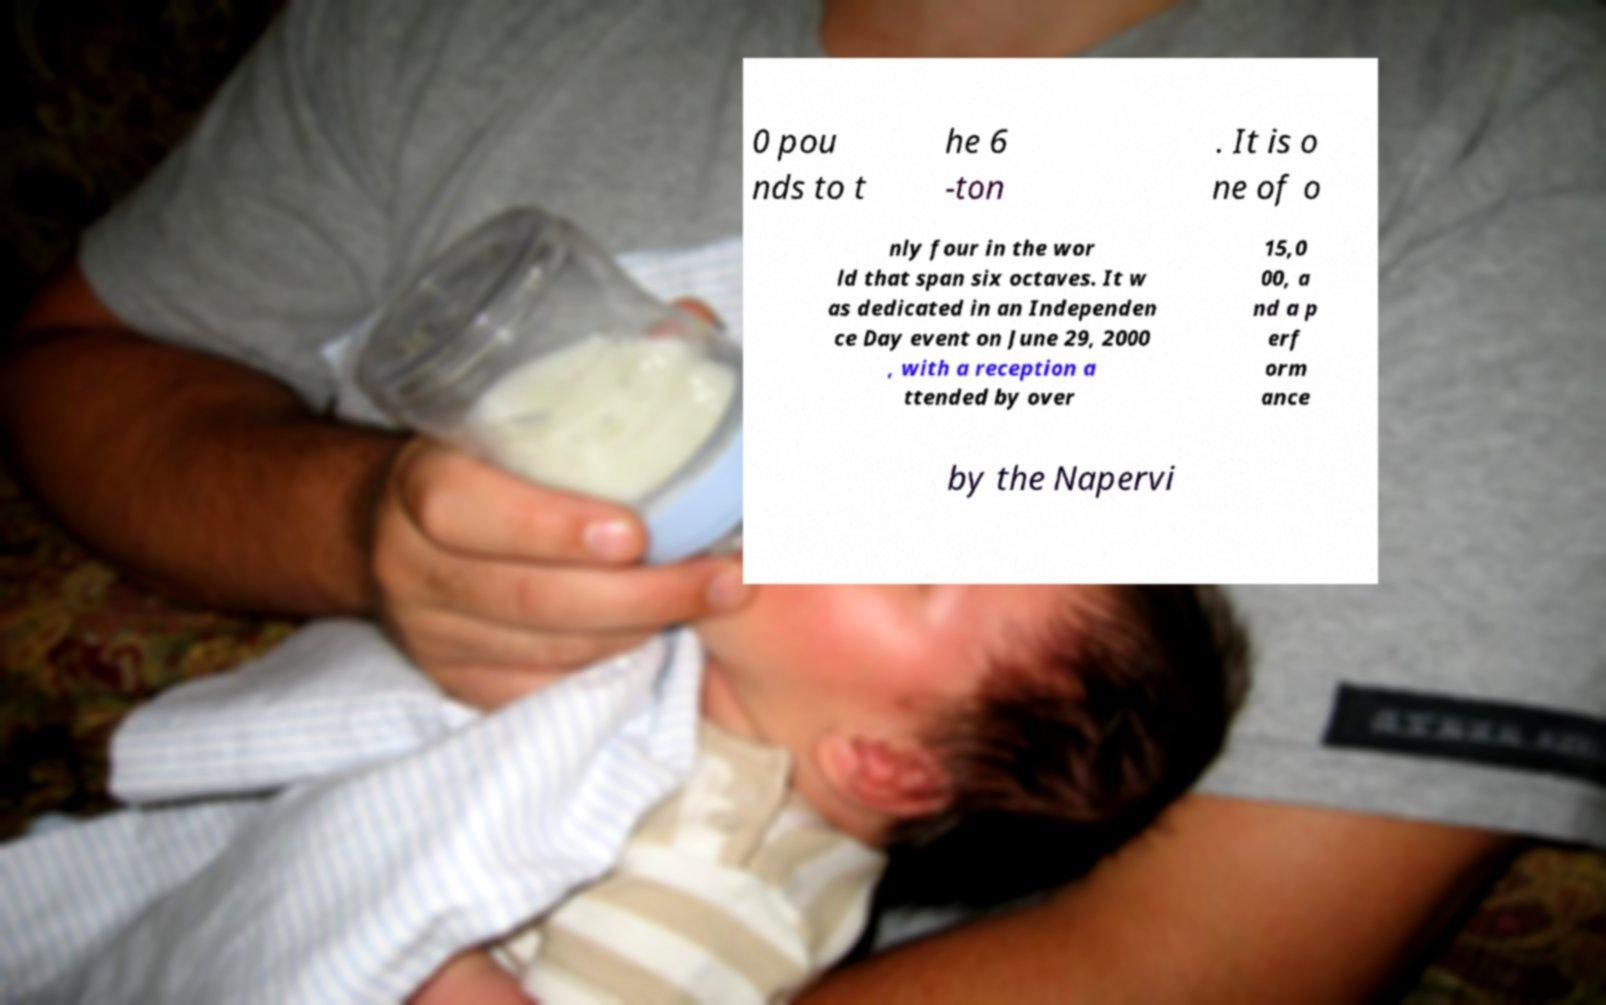Could you extract and type out the text from this image? 0 pou nds to t he 6 -ton . It is o ne of o nly four in the wor ld that span six octaves. It w as dedicated in an Independen ce Day event on June 29, 2000 , with a reception a ttended by over 15,0 00, a nd a p erf orm ance by the Napervi 